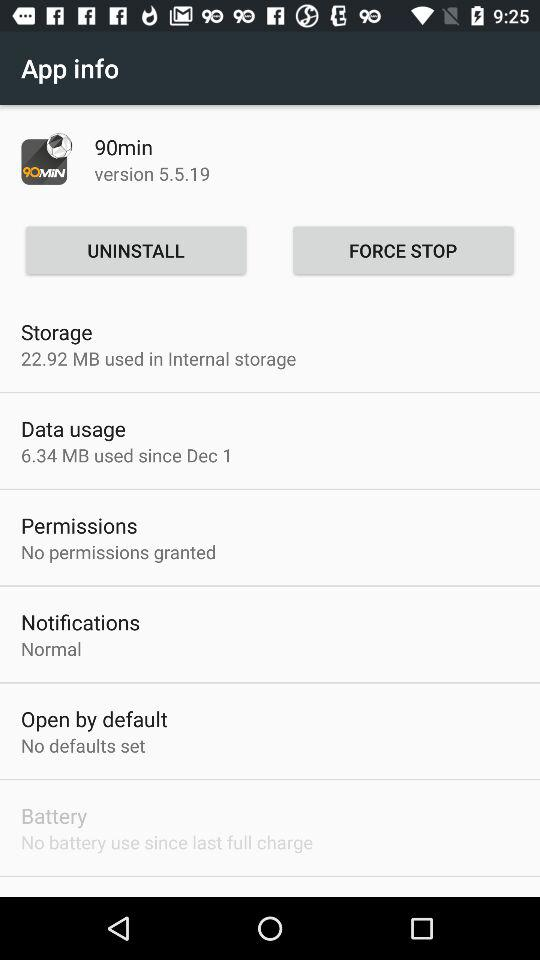Is it open by default? It is not open by default. 